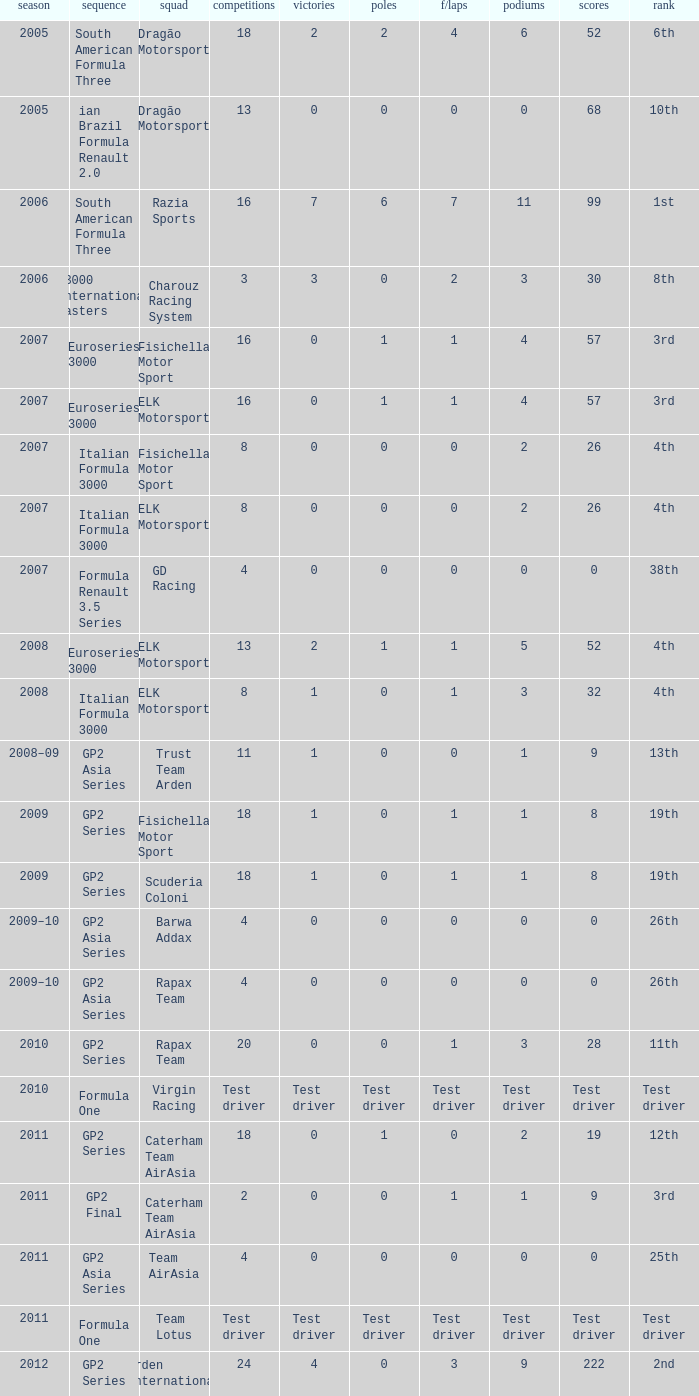In which season did he have 0 Poles and 19th position in the GP2 Series? 2009, 2009. 